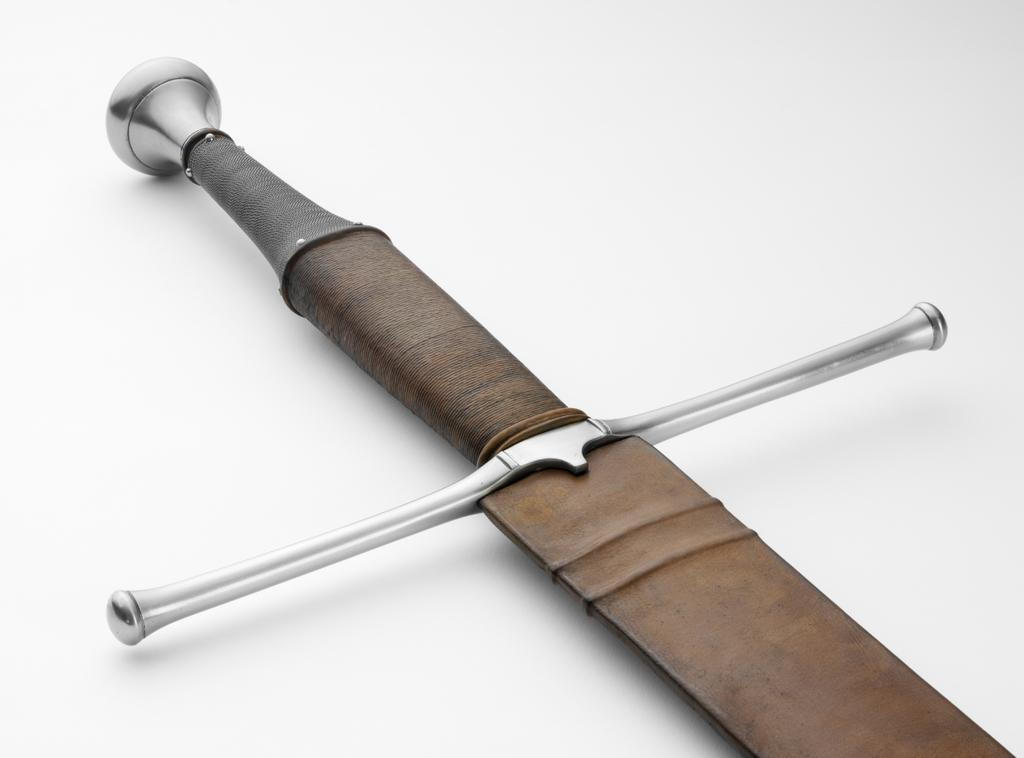What object can be seen in the image? There is a sword in the image. What is the color of the sword? The sword is brown in color. On what surface is the sword placed? The sword is placed on a white surface. How does the wind affect the sword in the image? There is no wind present in the image, so its effect on the sword cannot be determined. 